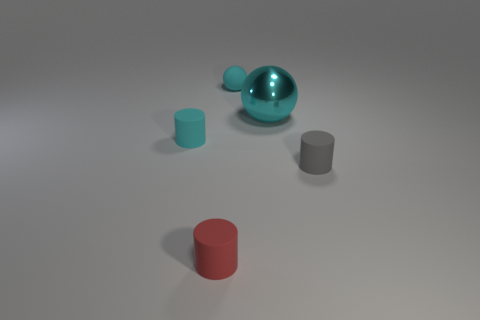Are there any other things that are the same material as the large cyan thing?
Your answer should be very brief. No. What number of other objects are there of the same color as the big metallic thing?
Your response must be concise. 2. What is the shape of the red matte object that is the same size as the gray cylinder?
Make the answer very short. Cylinder. There is a cylinder that is right of the red rubber object that is to the left of the large metallic sphere; how many tiny cylinders are left of it?
Give a very brief answer. 2. How many rubber things are small red cylinders or big brown objects?
Provide a succinct answer. 1. What color is the matte cylinder that is behind the small red thing and to the left of the tiny ball?
Provide a short and direct response. Cyan. Do the rubber sphere that is behind the red thing and the gray thing have the same size?
Offer a terse response. Yes. What number of things are tiny cyan things that are in front of the cyan matte sphere or large brown cylinders?
Make the answer very short. 1. Are there any brown matte things of the same size as the gray rubber object?
Your answer should be very brief. No. There is a red object that is the same size as the cyan matte cylinder; what material is it?
Ensure brevity in your answer.  Rubber. 